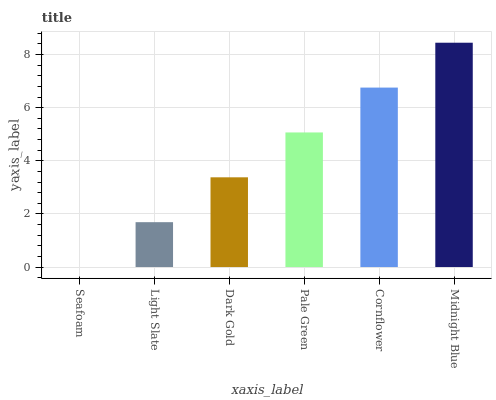Is Seafoam the minimum?
Answer yes or no. Yes. Is Midnight Blue the maximum?
Answer yes or no. Yes. Is Light Slate the minimum?
Answer yes or no. No. Is Light Slate the maximum?
Answer yes or no. No. Is Light Slate greater than Seafoam?
Answer yes or no. Yes. Is Seafoam less than Light Slate?
Answer yes or no. Yes. Is Seafoam greater than Light Slate?
Answer yes or no. No. Is Light Slate less than Seafoam?
Answer yes or no. No. Is Pale Green the high median?
Answer yes or no. Yes. Is Dark Gold the low median?
Answer yes or no. Yes. Is Seafoam the high median?
Answer yes or no. No. Is Cornflower the low median?
Answer yes or no. No. 